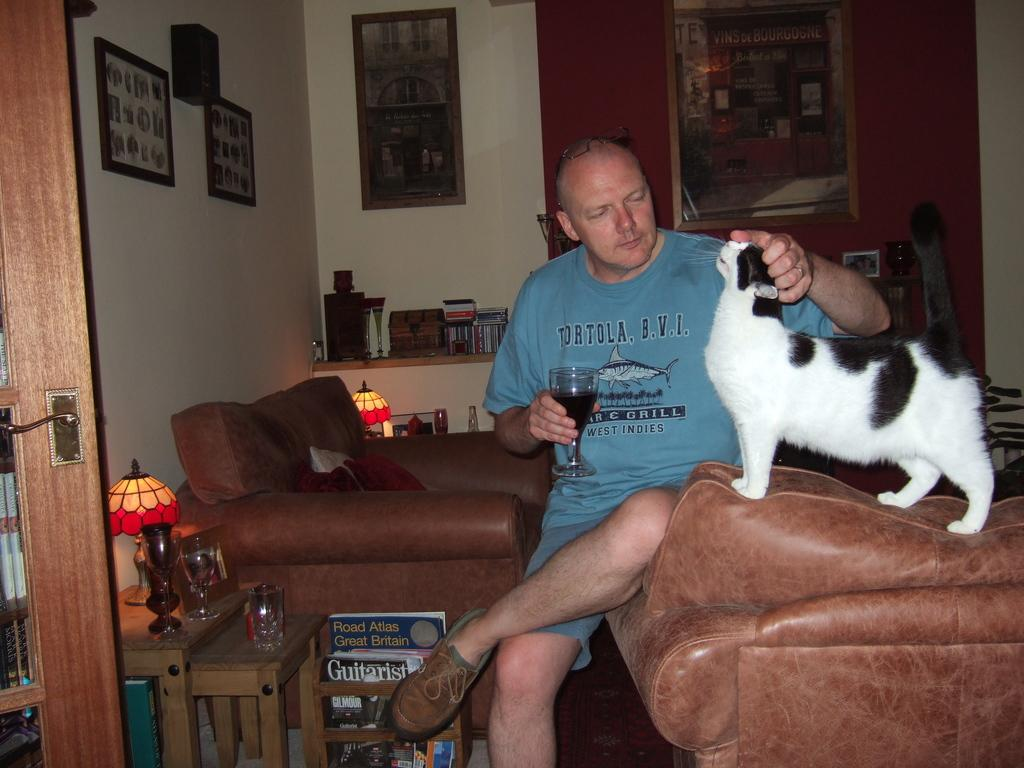Provide a one-sentence caption for the provided image. A man wearing a shirt that says 'tortola, b.v.i.'. 